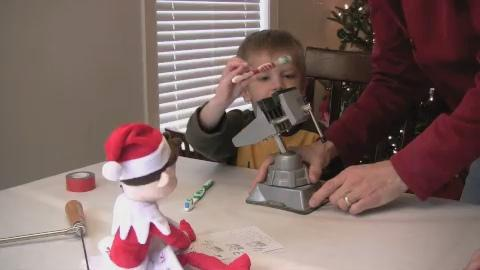Question: what color is the adult's shirt?
Choices:
A. Red.
B. Black.
C. Maroon.
D. White.
Answer with the letter. Answer: C Question: who is sitting down?
Choices:
A. The man.
B. The boy.
C. The lady.
D. The dog.
Answer with the letter. Answer: B Question: what is the toy?
Choices:
A. A ball.
B. Elf on the shelf.
C. A baby doll.
D. A dollhouse.
Answer with the letter. Answer: B 